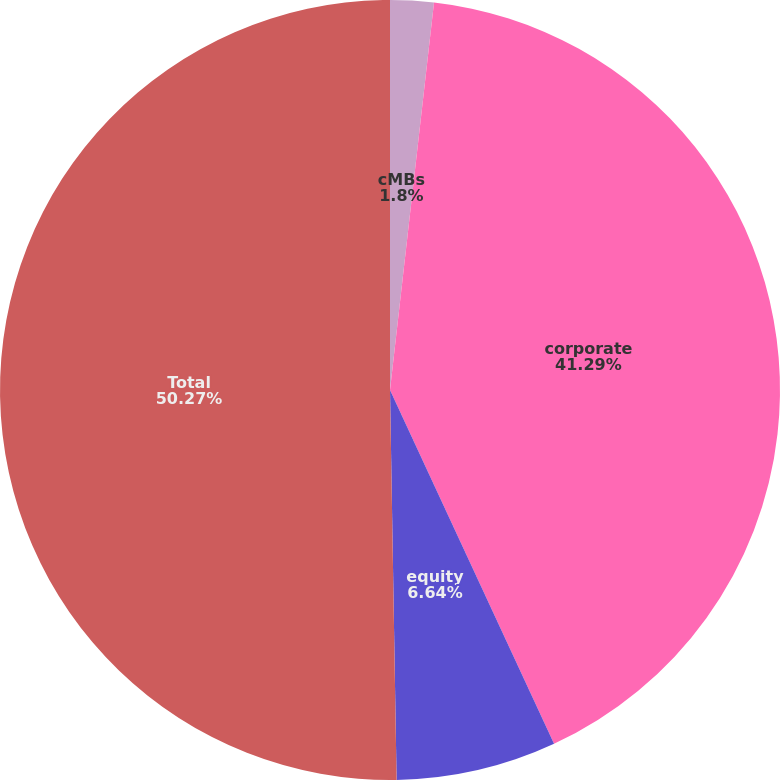<chart> <loc_0><loc_0><loc_500><loc_500><pie_chart><fcel>cMBs<fcel>corporate<fcel>equity<fcel>Total<nl><fcel>1.8%<fcel>41.29%<fcel>6.64%<fcel>50.27%<nl></chart> 